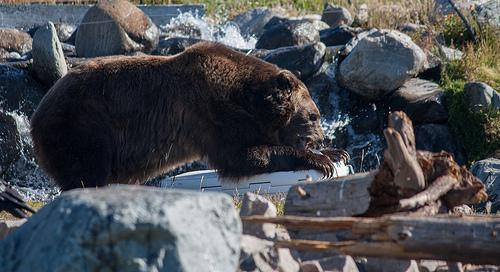Question: who is near the bear?
Choices:
A. The man.
B. The other bear.
C. The woman.
D. No one.
Answer with the letter. Answer: D 